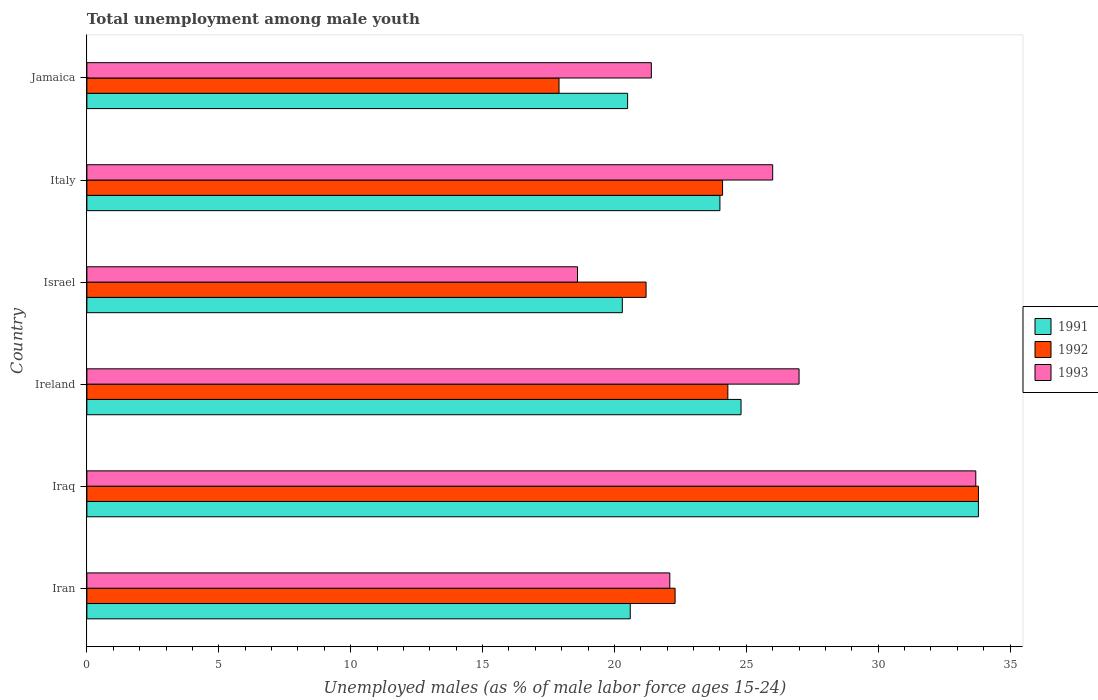How many different coloured bars are there?
Provide a succinct answer. 3. How many groups of bars are there?
Provide a short and direct response. 6. Are the number of bars per tick equal to the number of legend labels?
Offer a terse response. Yes. Are the number of bars on each tick of the Y-axis equal?
Offer a very short reply. Yes. What is the percentage of unemployed males in in 1992 in Italy?
Your answer should be compact. 24.1. Across all countries, what is the maximum percentage of unemployed males in in 1991?
Ensure brevity in your answer.  33.8. Across all countries, what is the minimum percentage of unemployed males in in 1991?
Keep it short and to the point. 20.3. In which country was the percentage of unemployed males in in 1991 maximum?
Provide a succinct answer. Iraq. In which country was the percentage of unemployed males in in 1992 minimum?
Ensure brevity in your answer.  Jamaica. What is the total percentage of unemployed males in in 1991 in the graph?
Offer a very short reply. 144. What is the difference between the percentage of unemployed males in in 1992 in Iran and that in Iraq?
Keep it short and to the point. -11.5. What is the difference between the percentage of unemployed males in in 1991 in Israel and the percentage of unemployed males in in 1992 in Ireland?
Make the answer very short. -4. What is the average percentage of unemployed males in in 1993 per country?
Ensure brevity in your answer.  24.8. What is the difference between the percentage of unemployed males in in 1992 and percentage of unemployed males in in 1993 in Iran?
Your response must be concise. 0.2. What is the ratio of the percentage of unemployed males in in 1991 in Iraq to that in Israel?
Ensure brevity in your answer.  1.67. What is the difference between the highest and the second highest percentage of unemployed males in in 1992?
Your response must be concise. 9.5. What is the difference between the highest and the lowest percentage of unemployed males in in 1991?
Make the answer very short. 13.5. What does the 3rd bar from the top in Israel represents?
Ensure brevity in your answer.  1991. What does the 2nd bar from the bottom in Italy represents?
Offer a terse response. 1992. Is it the case that in every country, the sum of the percentage of unemployed males in in 1993 and percentage of unemployed males in in 1991 is greater than the percentage of unemployed males in in 1992?
Make the answer very short. Yes. Are all the bars in the graph horizontal?
Give a very brief answer. Yes. What is the difference between two consecutive major ticks on the X-axis?
Your response must be concise. 5. Where does the legend appear in the graph?
Make the answer very short. Center right. How many legend labels are there?
Your answer should be compact. 3. What is the title of the graph?
Your response must be concise. Total unemployment among male youth. What is the label or title of the X-axis?
Offer a very short reply. Unemployed males (as % of male labor force ages 15-24). What is the Unemployed males (as % of male labor force ages 15-24) in 1991 in Iran?
Provide a succinct answer. 20.6. What is the Unemployed males (as % of male labor force ages 15-24) in 1992 in Iran?
Your answer should be very brief. 22.3. What is the Unemployed males (as % of male labor force ages 15-24) of 1993 in Iran?
Your answer should be very brief. 22.1. What is the Unemployed males (as % of male labor force ages 15-24) in 1991 in Iraq?
Your response must be concise. 33.8. What is the Unemployed males (as % of male labor force ages 15-24) in 1992 in Iraq?
Offer a terse response. 33.8. What is the Unemployed males (as % of male labor force ages 15-24) in 1993 in Iraq?
Ensure brevity in your answer.  33.7. What is the Unemployed males (as % of male labor force ages 15-24) of 1991 in Ireland?
Offer a very short reply. 24.8. What is the Unemployed males (as % of male labor force ages 15-24) in 1992 in Ireland?
Your answer should be compact. 24.3. What is the Unemployed males (as % of male labor force ages 15-24) in 1993 in Ireland?
Provide a short and direct response. 27. What is the Unemployed males (as % of male labor force ages 15-24) of 1991 in Israel?
Provide a short and direct response. 20.3. What is the Unemployed males (as % of male labor force ages 15-24) in 1992 in Israel?
Your answer should be very brief. 21.2. What is the Unemployed males (as % of male labor force ages 15-24) in 1993 in Israel?
Your response must be concise. 18.6. What is the Unemployed males (as % of male labor force ages 15-24) in 1992 in Italy?
Provide a short and direct response. 24.1. What is the Unemployed males (as % of male labor force ages 15-24) of 1993 in Italy?
Your response must be concise. 26. What is the Unemployed males (as % of male labor force ages 15-24) in 1991 in Jamaica?
Your answer should be very brief. 20.5. What is the Unemployed males (as % of male labor force ages 15-24) of 1992 in Jamaica?
Your answer should be compact. 17.9. What is the Unemployed males (as % of male labor force ages 15-24) in 1993 in Jamaica?
Offer a very short reply. 21.4. Across all countries, what is the maximum Unemployed males (as % of male labor force ages 15-24) of 1991?
Provide a short and direct response. 33.8. Across all countries, what is the maximum Unemployed males (as % of male labor force ages 15-24) in 1992?
Provide a succinct answer. 33.8. Across all countries, what is the maximum Unemployed males (as % of male labor force ages 15-24) in 1993?
Give a very brief answer. 33.7. Across all countries, what is the minimum Unemployed males (as % of male labor force ages 15-24) of 1991?
Your answer should be compact. 20.3. Across all countries, what is the minimum Unemployed males (as % of male labor force ages 15-24) in 1992?
Provide a succinct answer. 17.9. Across all countries, what is the minimum Unemployed males (as % of male labor force ages 15-24) of 1993?
Give a very brief answer. 18.6. What is the total Unemployed males (as % of male labor force ages 15-24) of 1991 in the graph?
Your answer should be very brief. 144. What is the total Unemployed males (as % of male labor force ages 15-24) in 1992 in the graph?
Offer a terse response. 143.6. What is the total Unemployed males (as % of male labor force ages 15-24) in 1993 in the graph?
Ensure brevity in your answer.  148.8. What is the difference between the Unemployed males (as % of male labor force ages 15-24) in 1991 in Iran and that in Iraq?
Make the answer very short. -13.2. What is the difference between the Unemployed males (as % of male labor force ages 15-24) in 1992 in Iran and that in Iraq?
Provide a succinct answer. -11.5. What is the difference between the Unemployed males (as % of male labor force ages 15-24) of 1993 in Iran and that in Iraq?
Keep it short and to the point. -11.6. What is the difference between the Unemployed males (as % of male labor force ages 15-24) of 1992 in Iran and that in Ireland?
Make the answer very short. -2. What is the difference between the Unemployed males (as % of male labor force ages 15-24) in 1993 in Iran and that in Ireland?
Your response must be concise. -4.9. What is the difference between the Unemployed males (as % of male labor force ages 15-24) in 1991 in Iran and that in Italy?
Provide a succinct answer. -3.4. What is the difference between the Unemployed males (as % of male labor force ages 15-24) in 1993 in Iran and that in Italy?
Your answer should be very brief. -3.9. What is the difference between the Unemployed males (as % of male labor force ages 15-24) of 1993 in Iraq and that in Ireland?
Give a very brief answer. 6.7. What is the difference between the Unemployed males (as % of male labor force ages 15-24) of 1992 in Iraq and that in Israel?
Offer a terse response. 12.6. What is the difference between the Unemployed males (as % of male labor force ages 15-24) of 1993 in Iraq and that in Israel?
Provide a short and direct response. 15.1. What is the difference between the Unemployed males (as % of male labor force ages 15-24) of 1991 in Iraq and that in Italy?
Your answer should be very brief. 9.8. What is the difference between the Unemployed males (as % of male labor force ages 15-24) of 1993 in Iraq and that in Italy?
Your response must be concise. 7.7. What is the difference between the Unemployed males (as % of male labor force ages 15-24) of 1991 in Iraq and that in Jamaica?
Ensure brevity in your answer.  13.3. What is the difference between the Unemployed males (as % of male labor force ages 15-24) in 1992 in Iraq and that in Jamaica?
Provide a short and direct response. 15.9. What is the difference between the Unemployed males (as % of male labor force ages 15-24) in 1991 in Ireland and that in Israel?
Give a very brief answer. 4.5. What is the difference between the Unemployed males (as % of male labor force ages 15-24) of 1992 in Ireland and that in Israel?
Your response must be concise. 3.1. What is the difference between the Unemployed males (as % of male labor force ages 15-24) of 1992 in Ireland and that in Italy?
Provide a short and direct response. 0.2. What is the difference between the Unemployed males (as % of male labor force ages 15-24) in 1993 in Ireland and that in Italy?
Offer a terse response. 1. What is the difference between the Unemployed males (as % of male labor force ages 15-24) of 1991 in Ireland and that in Jamaica?
Provide a succinct answer. 4.3. What is the difference between the Unemployed males (as % of male labor force ages 15-24) of 1992 in Israel and that in Italy?
Offer a terse response. -2.9. What is the difference between the Unemployed males (as % of male labor force ages 15-24) in 1991 in Israel and that in Jamaica?
Your response must be concise. -0.2. What is the difference between the Unemployed males (as % of male labor force ages 15-24) of 1993 in Israel and that in Jamaica?
Offer a terse response. -2.8. What is the difference between the Unemployed males (as % of male labor force ages 15-24) of 1991 in Italy and that in Jamaica?
Your response must be concise. 3.5. What is the difference between the Unemployed males (as % of male labor force ages 15-24) in 1992 in Italy and that in Jamaica?
Offer a terse response. 6.2. What is the difference between the Unemployed males (as % of male labor force ages 15-24) of 1993 in Italy and that in Jamaica?
Offer a very short reply. 4.6. What is the difference between the Unemployed males (as % of male labor force ages 15-24) in 1991 in Iran and the Unemployed males (as % of male labor force ages 15-24) in 1992 in Iraq?
Give a very brief answer. -13.2. What is the difference between the Unemployed males (as % of male labor force ages 15-24) in 1991 in Iran and the Unemployed males (as % of male labor force ages 15-24) in 1993 in Ireland?
Make the answer very short. -6.4. What is the difference between the Unemployed males (as % of male labor force ages 15-24) in 1992 in Iran and the Unemployed males (as % of male labor force ages 15-24) in 1993 in Ireland?
Provide a succinct answer. -4.7. What is the difference between the Unemployed males (as % of male labor force ages 15-24) of 1991 in Iran and the Unemployed males (as % of male labor force ages 15-24) of 1992 in Israel?
Your response must be concise. -0.6. What is the difference between the Unemployed males (as % of male labor force ages 15-24) in 1992 in Iran and the Unemployed males (as % of male labor force ages 15-24) in 1993 in Israel?
Provide a short and direct response. 3.7. What is the difference between the Unemployed males (as % of male labor force ages 15-24) of 1991 in Iran and the Unemployed males (as % of male labor force ages 15-24) of 1993 in Italy?
Your answer should be very brief. -5.4. What is the difference between the Unemployed males (as % of male labor force ages 15-24) in 1992 in Iran and the Unemployed males (as % of male labor force ages 15-24) in 1993 in Italy?
Give a very brief answer. -3.7. What is the difference between the Unemployed males (as % of male labor force ages 15-24) in 1992 in Iran and the Unemployed males (as % of male labor force ages 15-24) in 1993 in Jamaica?
Keep it short and to the point. 0.9. What is the difference between the Unemployed males (as % of male labor force ages 15-24) in 1991 in Iraq and the Unemployed males (as % of male labor force ages 15-24) in 1993 in Ireland?
Make the answer very short. 6.8. What is the difference between the Unemployed males (as % of male labor force ages 15-24) of 1992 in Iraq and the Unemployed males (as % of male labor force ages 15-24) of 1993 in Ireland?
Give a very brief answer. 6.8. What is the difference between the Unemployed males (as % of male labor force ages 15-24) of 1991 in Iraq and the Unemployed males (as % of male labor force ages 15-24) of 1992 in Italy?
Ensure brevity in your answer.  9.7. What is the difference between the Unemployed males (as % of male labor force ages 15-24) in 1991 in Iraq and the Unemployed males (as % of male labor force ages 15-24) in 1993 in Italy?
Your answer should be compact. 7.8. What is the difference between the Unemployed males (as % of male labor force ages 15-24) in 1992 in Iraq and the Unemployed males (as % of male labor force ages 15-24) in 1993 in Italy?
Provide a short and direct response. 7.8. What is the difference between the Unemployed males (as % of male labor force ages 15-24) of 1991 in Iraq and the Unemployed males (as % of male labor force ages 15-24) of 1993 in Jamaica?
Offer a terse response. 12.4. What is the difference between the Unemployed males (as % of male labor force ages 15-24) of 1991 in Ireland and the Unemployed males (as % of male labor force ages 15-24) of 1992 in Israel?
Your answer should be very brief. 3.6. What is the difference between the Unemployed males (as % of male labor force ages 15-24) of 1991 in Ireland and the Unemployed males (as % of male labor force ages 15-24) of 1993 in Israel?
Your response must be concise. 6.2. What is the difference between the Unemployed males (as % of male labor force ages 15-24) in 1991 in Ireland and the Unemployed males (as % of male labor force ages 15-24) in 1992 in Jamaica?
Your answer should be very brief. 6.9. What is the difference between the Unemployed males (as % of male labor force ages 15-24) in 1991 in Ireland and the Unemployed males (as % of male labor force ages 15-24) in 1993 in Jamaica?
Provide a short and direct response. 3.4. What is the difference between the Unemployed males (as % of male labor force ages 15-24) in 1992 in Ireland and the Unemployed males (as % of male labor force ages 15-24) in 1993 in Jamaica?
Keep it short and to the point. 2.9. What is the difference between the Unemployed males (as % of male labor force ages 15-24) of 1991 in Israel and the Unemployed males (as % of male labor force ages 15-24) of 1992 in Italy?
Provide a short and direct response. -3.8. What is the difference between the Unemployed males (as % of male labor force ages 15-24) of 1992 in Israel and the Unemployed males (as % of male labor force ages 15-24) of 1993 in Italy?
Ensure brevity in your answer.  -4.8. What is the difference between the Unemployed males (as % of male labor force ages 15-24) of 1991 in Israel and the Unemployed males (as % of male labor force ages 15-24) of 1993 in Jamaica?
Make the answer very short. -1.1. What is the difference between the Unemployed males (as % of male labor force ages 15-24) of 1991 in Italy and the Unemployed males (as % of male labor force ages 15-24) of 1992 in Jamaica?
Offer a terse response. 6.1. What is the average Unemployed males (as % of male labor force ages 15-24) of 1992 per country?
Keep it short and to the point. 23.93. What is the average Unemployed males (as % of male labor force ages 15-24) of 1993 per country?
Your answer should be very brief. 24.8. What is the difference between the Unemployed males (as % of male labor force ages 15-24) of 1991 and Unemployed males (as % of male labor force ages 15-24) of 1992 in Iran?
Make the answer very short. -1.7. What is the difference between the Unemployed males (as % of male labor force ages 15-24) of 1991 and Unemployed males (as % of male labor force ages 15-24) of 1993 in Iraq?
Offer a terse response. 0.1. What is the difference between the Unemployed males (as % of male labor force ages 15-24) of 1992 and Unemployed males (as % of male labor force ages 15-24) of 1993 in Iraq?
Offer a very short reply. 0.1. What is the difference between the Unemployed males (as % of male labor force ages 15-24) of 1991 and Unemployed males (as % of male labor force ages 15-24) of 1992 in Israel?
Your response must be concise. -0.9. What is the difference between the Unemployed males (as % of male labor force ages 15-24) of 1991 and Unemployed males (as % of male labor force ages 15-24) of 1993 in Italy?
Make the answer very short. -2. What is the difference between the Unemployed males (as % of male labor force ages 15-24) of 1991 and Unemployed males (as % of male labor force ages 15-24) of 1992 in Jamaica?
Provide a short and direct response. 2.6. What is the difference between the Unemployed males (as % of male labor force ages 15-24) of 1991 and Unemployed males (as % of male labor force ages 15-24) of 1993 in Jamaica?
Make the answer very short. -0.9. What is the difference between the Unemployed males (as % of male labor force ages 15-24) in 1992 and Unemployed males (as % of male labor force ages 15-24) in 1993 in Jamaica?
Provide a succinct answer. -3.5. What is the ratio of the Unemployed males (as % of male labor force ages 15-24) of 1991 in Iran to that in Iraq?
Your response must be concise. 0.61. What is the ratio of the Unemployed males (as % of male labor force ages 15-24) in 1992 in Iran to that in Iraq?
Provide a succinct answer. 0.66. What is the ratio of the Unemployed males (as % of male labor force ages 15-24) of 1993 in Iran to that in Iraq?
Offer a very short reply. 0.66. What is the ratio of the Unemployed males (as % of male labor force ages 15-24) of 1991 in Iran to that in Ireland?
Ensure brevity in your answer.  0.83. What is the ratio of the Unemployed males (as % of male labor force ages 15-24) of 1992 in Iran to that in Ireland?
Make the answer very short. 0.92. What is the ratio of the Unemployed males (as % of male labor force ages 15-24) of 1993 in Iran to that in Ireland?
Your answer should be very brief. 0.82. What is the ratio of the Unemployed males (as % of male labor force ages 15-24) in 1991 in Iran to that in Israel?
Make the answer very short. 1.01. What is the ratio of the Unemployed males (as % of male labor force ages 15-24) in 1992 in Iran to that in Israel?
Keep it short and to the point. 1.05. What is the ratio of the Unemployed males (as % of male labor force ages 15-24) in 1993 in Iran to that in Israel?
Your answer should be compact. 1.19. What is the ratio of the Unemployed males (as % of male labor force ages 15-24) of 1991 in Iran to that in Italy?
Your response must be concise. 0.86. What is the ratio of the Unemployed males (as % of male labor force ages 15-24) of 1992 in Iran to that in Italy?
Provide a short and direct response. 0.93. What is the ratio of the Unemployed males (as % of male labor force ages 15-24) in 1993 in Iran to that in Italy?
Offer a terse response. 0.85. What is the ratio of the Unemployed males (as % of male labor force ages 15-24) of 1992 in Iran to that in Jamaica?
Your response must be concise. 1.25. What is the ratio of the Unemployed males (as % of male labor force ages 15-24) of 1993 in Iran to that in Jamaica?
Keep it short and to the point. 1.03. What is the ratio of the Unemployed males (as % of male labor force ages 15-24) of 1991 in Iraq to that in Ireland?
Ensure brevity in your answer.  1.36. What is the ratio of the Unemployed males (as % of male labor force ages 15-24) of 1992 in Iraq to that in Ireland?
Give a very brief answer. 1.39. What is the ratio of the Unemployed males (as % of male labor force ages 15-24) in 1993 in Iraq to that in Ireland?
Your answer should be compact. 1.25. What is the ratio of the Unemployed males (as % of male labor force ages 15-24) in 1991 in Iraq to that in Israel?
Keep it short and to the point. 1.67. What is the ratio of the Unemployed males (as % of male labor force ages 15-24) of 1992 in Iraq to that in Israel?
Provide a succinct answer. 1.59. What is the ratio of the Unemployed males (as % of male labor force ages 15-24) of 1993 in Iraq to that in Israel?
Ensure brevity in your answer.  1.81. What is the ratio of the Unemployed males (as % of male labor force ages 15-24) in 1991 in Iraq to that in Italy?
Your answer should be very brief. 1.41. What is the ratio of the Unemployed males (as % of male labor force ages 15-24) of 1992 in Iraq to that in Italy?
Make the answer very short. 1.4. What is the ratio of the Unemployed males (as % of male labor force ages 15-24) in 1993 in Iraq to that in Italy?
Keep it short and to the point. 1.3. What is the ratio of the Unemployed males (as % of male labor force ages 15-24) of 1991 in Iraq to that in Jamaica?
Offer a very short reply. 1.65. What is the ratio of the Unemployed males (as % of male labor force ages 15-24) in 1992 in Iraq to that in Jamaica?
Your answer should be very brief. 1.89. What is the ratio of the Unemployed males (as % of male labor force ages 15-24) in 1993 in Iraq to that in Jamaica?
Your answer should be very brief. 1.57. What is the ratio of the Unemployed males (as % of male labor force ages 15-24) of 1991 in Ireland to that in Israel?
Your answer should be very brief. 1.22. What is the ratio of the Unemployed males (as % of male labor force ages 15-24) of 1992 in Ireland to that in Israel?
Keep it short and to the point. 1.15. What is the ratio of the Unemployed males (as % of male labor force ages 15-24) of 1993 in Ireland to that in Israel?
Give a very brief answer. 1.45. What is the ratio of the Unemployed males (as % of male labor force ages 15-24) in 1991 in Ireland to that in Italy?
Your response must be concise. 1.03. What is the ratio of the Unemployed males (as % of male labor force ages 15-24) in 1992 in Ireland to that in Italy?
Provide a short and direct response. 1.01. What is the ratio of the Unemployed males (as % of male labor force ages 15-24) in 1993 in Ireland to that in Italy?
Make the answer very short. 1.04. What is the ratio of the Unemployed males (as % of male labor force ages 15-24) in 1991 in Ireland to that in Jamaica?
Your answer should be compact. 1.21. What is the ratio of the Unemployed males (as % of male labor force ages 15-24) of 1992 in Ireland to that in Jamaica?
Ensure brevity in your answer.  1.36. What is the ratio of the Unemployed males (as % of male labor force ages 15-24) in 1993 in Ireland to that in Jamaica?
Provide a short and direct response. 1.26. What is the ratio of the Unemployed males (as % of male labor force ages 15-24) of 1991 in Israel to that in Italy?
Provide a short and direct response. 0.85. What is the ratio of the Unemployed males (as % of male labor force ages 15-24) in 1992 in Israel to that in Italy?
Offer a terse response. 0.88. What is the ratio of the Unemployed males (as % of male labor force ages 15-24) of 1993 in Israel to that in Italy?
Offer a terse response. 0.72. What is the ratio of the Unemployed males (as % of male labor force ages 15-24) in 1991 in Israel to that in Jamaica?
Make the answer very short. 0.99. What is the ratio of the Unemployed males (as % of male labor force ages 15-24) of 1992 in Israel to that in Jamaica?
Your answer should be compact. 1.18. What is the ratio of the Unemployed males (as % of male labor force ages 15-24) in 1993 in Israel to that in Jamaica?
Your answer should be very brief. 0.87. What is the ratio of the Unemployed males (as % of male labor force ages 15-24) of 1991 in Italy to that in Jamaica?
Give a very brief answer. 1.17. What is the ratio of the Unemployed males (as % of male labor force ages 15-24) of 1992 in Italy to that in Jamaica?
Ensure brevity in your answer.  1.35. What is the ratio of the Unemployed males (as % of male labor force ages 15-24) of 1993 in Italy to that in Jamaica?
Your response must be concise. 1.22. What is the difference between the highest and the second highest Unemployed males (as % of male labor force ages 15-24) in 1991?
Your answer should be very brief. 9. 